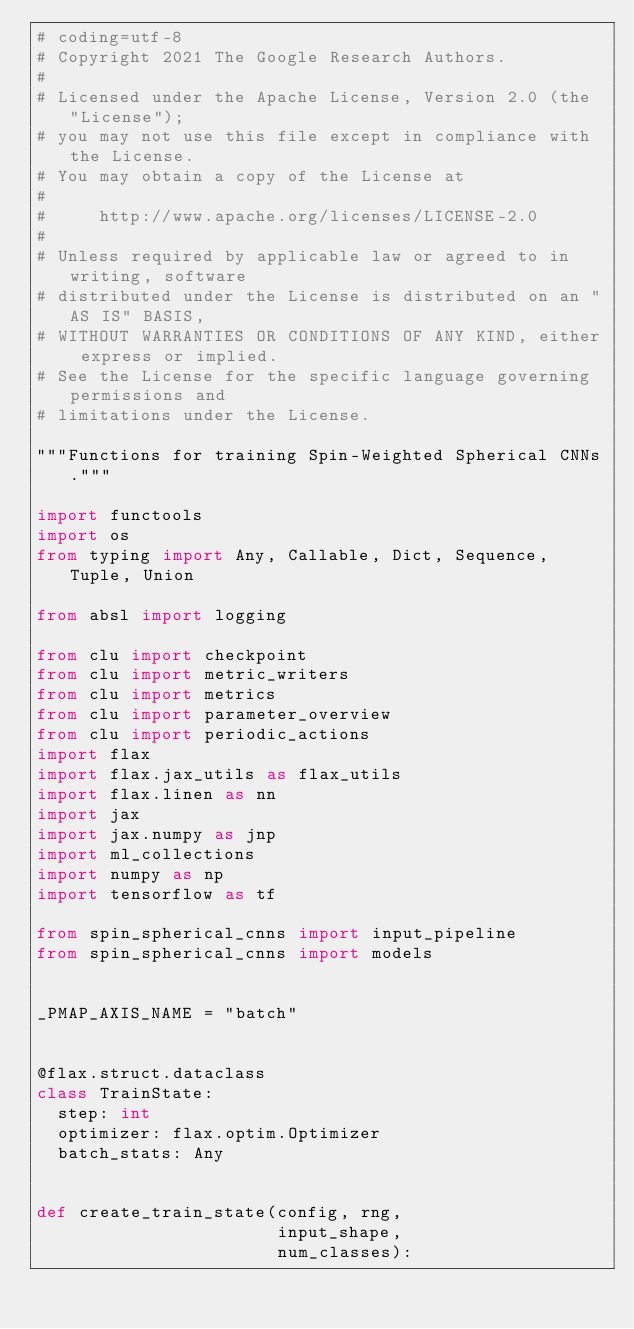<code> <loc_0><loc_0><loc_500><loc_500><_Python_># coding=utf-8
# Copyright 2021 The Google Research Authors.
#
# Licensed under the Apache License, Version 2.0 (the "License");
# you may not use this file except in compliance with the License.
# You may obtain a copy of the License at
#
#     http://www.apache.org/licenses/LICENSE-2.0
#
# Unless required by applicable law or agreed to in writing, software
# distributed under the License is distributed on an "AS IS" BASIS,
# WITHOUT WARRANTIES OR CONDITIONS OF ANY KIND, either express or implied.
# See the License for the specific language governing permissions and
# limitations under the License.

"""Functions for training Spin-Weighted Spherical CNNs."""

import functools
import os
from typing import Any, Callable, Dict, Sequence, Tuple, Union

from absl import logging

from clu import checkpoint
from clu import metric_writers
from clu import metrics
from clu import parameter_overview
from clu import periodic_actions
import flax
import flax.jax_utils as flax_utils
import flax.linen as nn
import jax
import jax.numpy as jnp
import ml_collections
import numpy as np
import tensorflow as tf

from spin_spherical_cnns import input_pipeline
from spin_spherical_cnns import models


_PMAP_AXIS_NAME = "batch"


@flax.struct.dataclass
class TrainState:
  step: int
  optimizer: flax.optim.Optimizer
  batch_stats: Any


def create_train_state(config, rng,
                       input_shape,
                       num_classes):</code> 